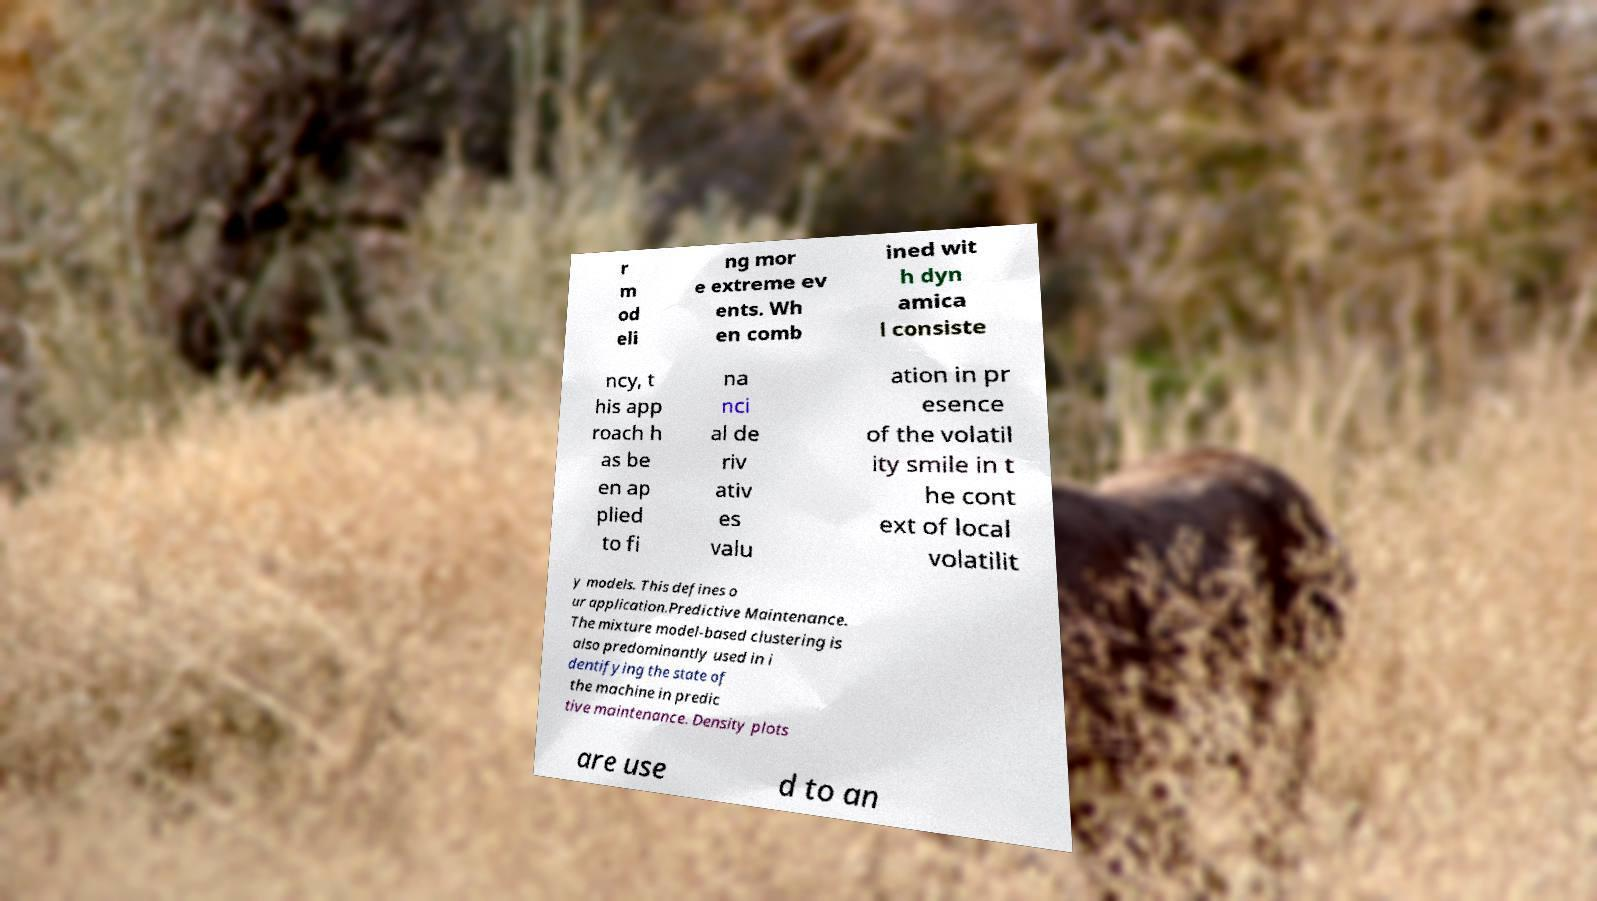Please read and relay the text visible in this image. What does it say? r m od eli ng mor e extreme ev ents. Wh en comb ined wit h dyn amica l consiste ncy, t his app roach h as be en ap plied to fi na nci al de riv ativ es valu ation in pr esence of the volatil ity smile in t he cont ext of local volatilit y models. This defines o ur application.Predictive Maintenance. The mixture model-based clustering is also predominantly used in i dentifying the state of the machine in predic tive maintenance. Density plots are use d to an 